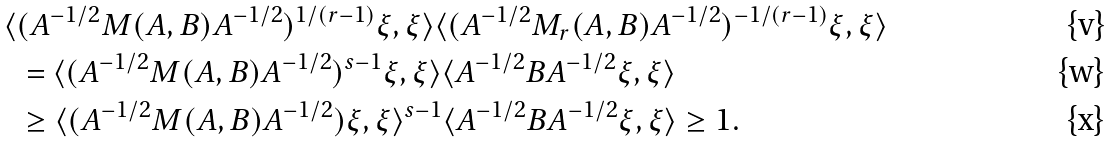<formula> <loc_0><loc_0><loc_500><loc_500>\langle & ( A ^ { - 1 / 2 } M ( A , B ) A ^ { - 1 / 2 } ) ^ { 1 / ( r - 1 ) } \xi , \xi \rangle \langle ( A ^ { - 1 / 2 } M _ { r } ( A , B ) A ^ { - 1 / 2 } ) ^ { - 1 / ( r - 1 ) } \xi , \xi \rangle \\ & = \langle ( A ^ { - 1 / 2 } M ( A , B ) A ^ { - 1 / 2 } ) ^ { s - 1 } \xi , \xi \rangle \langle A ^ { - 1 / 2 } B A ^ { - 1 / 2 } \xi , \xi \rangle \\ & \geq \langle ( A ^ { - 1 / 2 } M ( A , B ) A ^ { - 1 / 2 } ) \xi , \xi \rangle ^ { s - 1 } \langle A ^ { - 1 / 2 } B A ^ { - 1 / 2 } \xi , \xi \rangle \geq 1 .</formula> 